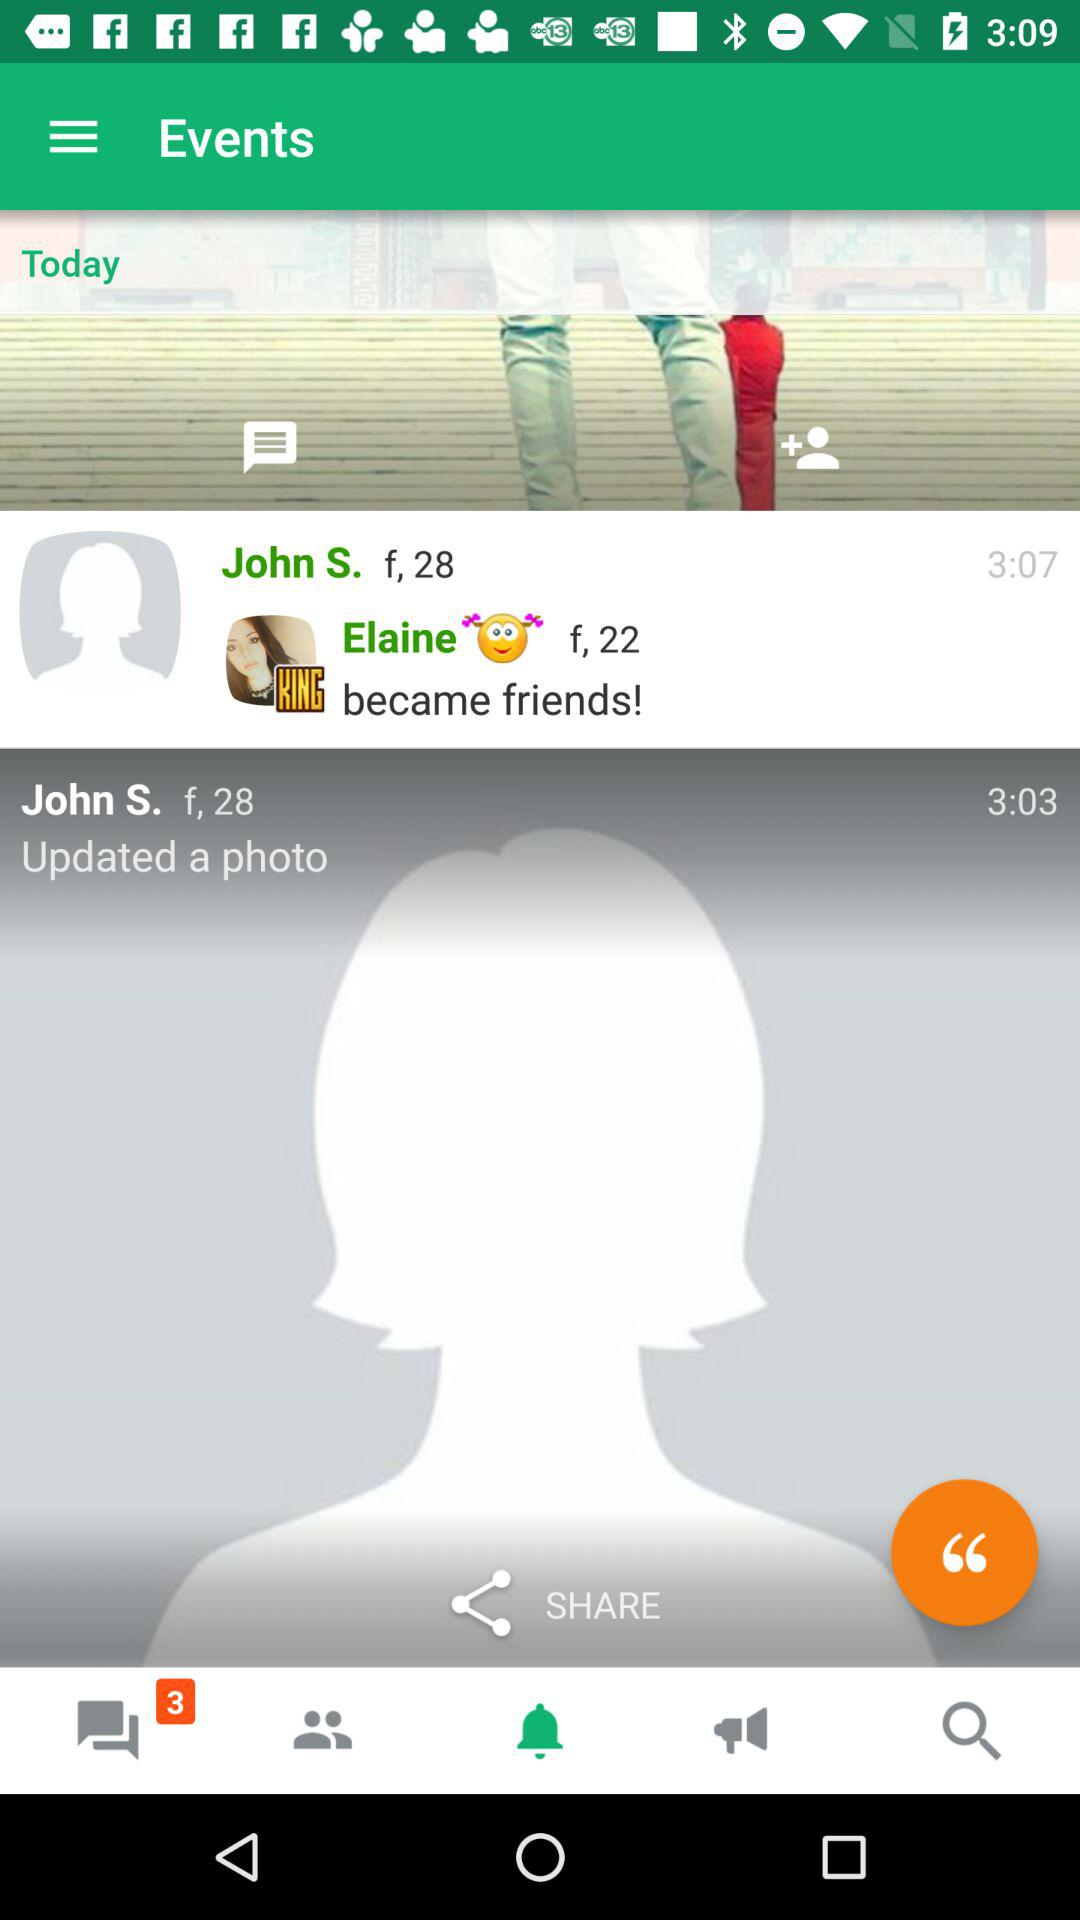What is the age of Elaine? Elaine's age is 22 years old. 